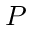Convert formula to latex. <formula><loc_0><loc_0><loc_500><loc_500>P</formula> 